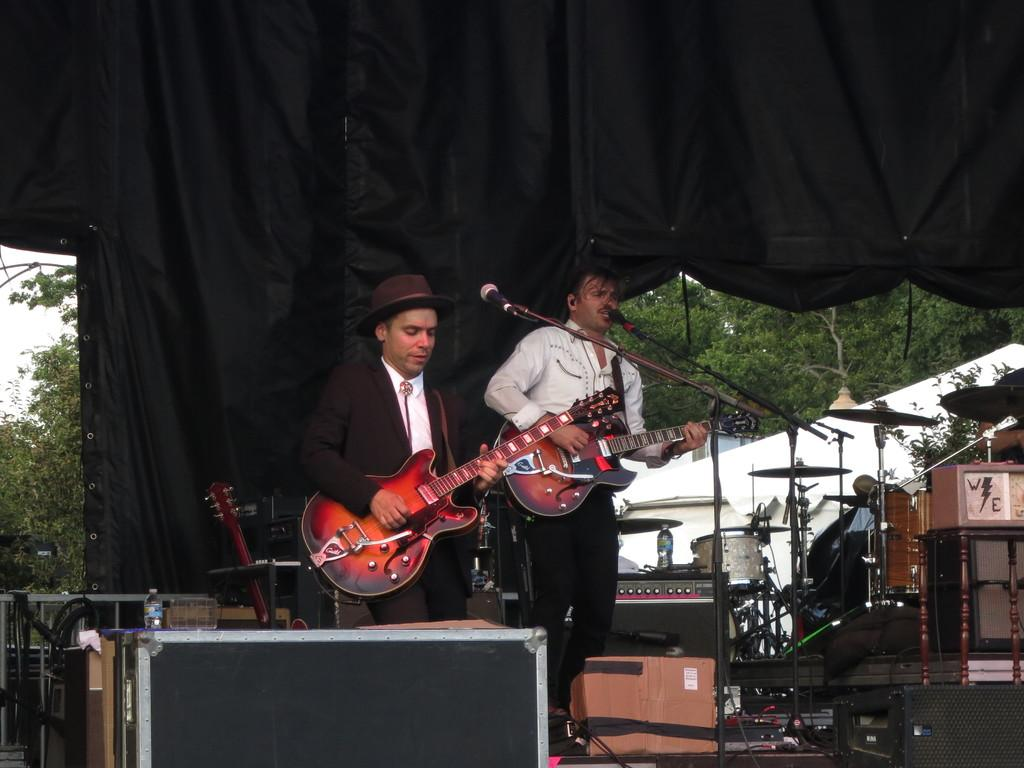What color is the cloth visible in the image? The cloth in the image is black. How many people are present in the image? Two people are standing in the image. What are the people holding in the image? The people are holding guitars. What device is present for amplifying sound in the image? There is a microphone in the image. What type of musical instrument can be seen on the right side of the image? There are musical drums on the right side of the image. What substance is being consumed by the people in the image during the afternoon? There is no indication of any substance being consumed in the image, and the time of day is not specified. 